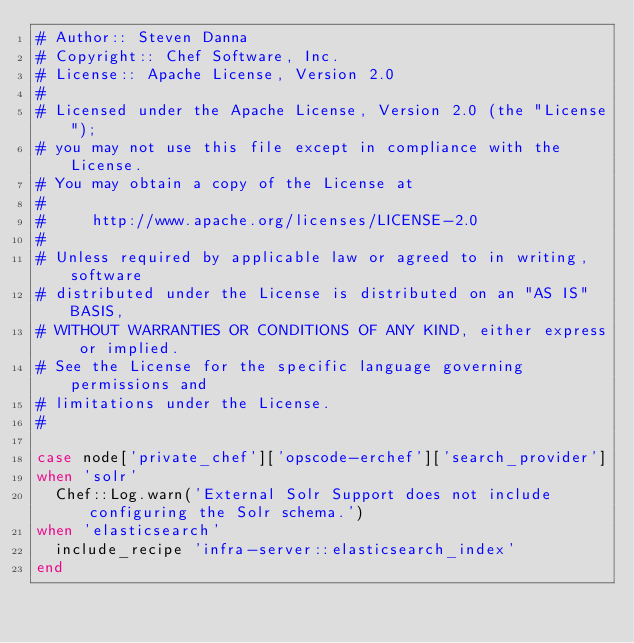Convert code to text. <code><loc_0><loc_0><loc_500><loc_500><_Ruby_># Author:: Steven Danna
# Copyright:: Chef Software, Inc.
# License:: Apache License, Version 2.0
#
# Licensed under the Apache License, Version 2.0 (the "License");
# you may not use this file except in compliance with the License.
# You may obtain a copy of the License at
#
#     http://www.apache.org/licenses/LICENSE-2.0
#
# Unless required by applicable law or agreed to in writing, software
# distributed under the License is distributed on an "AS IS" BASIS,
# WITHOUT WARRANTIES OR CONDITIONS OF ANY KIND, either express or implied.
# See the License for the specific language governing permissions and
# limitations under the License.
#

case node['private_chef']['opscode-erchef']['search_provider']
when 'solr'
  Chef::Log.warn('External Solr Support does not include configuring the Solr schema.')
when 'elasticsearch'
  include_recipe 'infra-server::elasticsearch_index'
end
</code> 